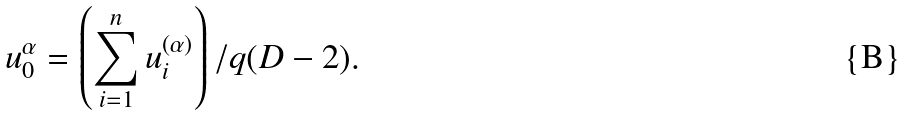Convert formula to latex. <formula><loc_0><loc_0><loc_500><loc_500>u ^ { \alpha } _ { 0 } = \left ( \sum _ { i = 1 } ^ { n } u ^ { ( \alpha ) } _ { i } \right ) / q ( D - 2 ) .</formula> 